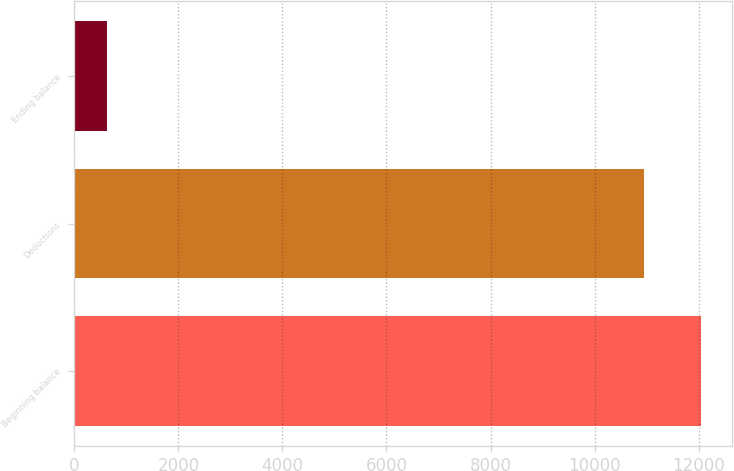<chart> <loc_0><loc_0><loc_500><loc_500><bar_chart><fcel>Beginning balance<fcel>Deductions<fcel>Ending balance<nl><fcel>12037.3<fcel>10943<fcel>632<nl></chart> 